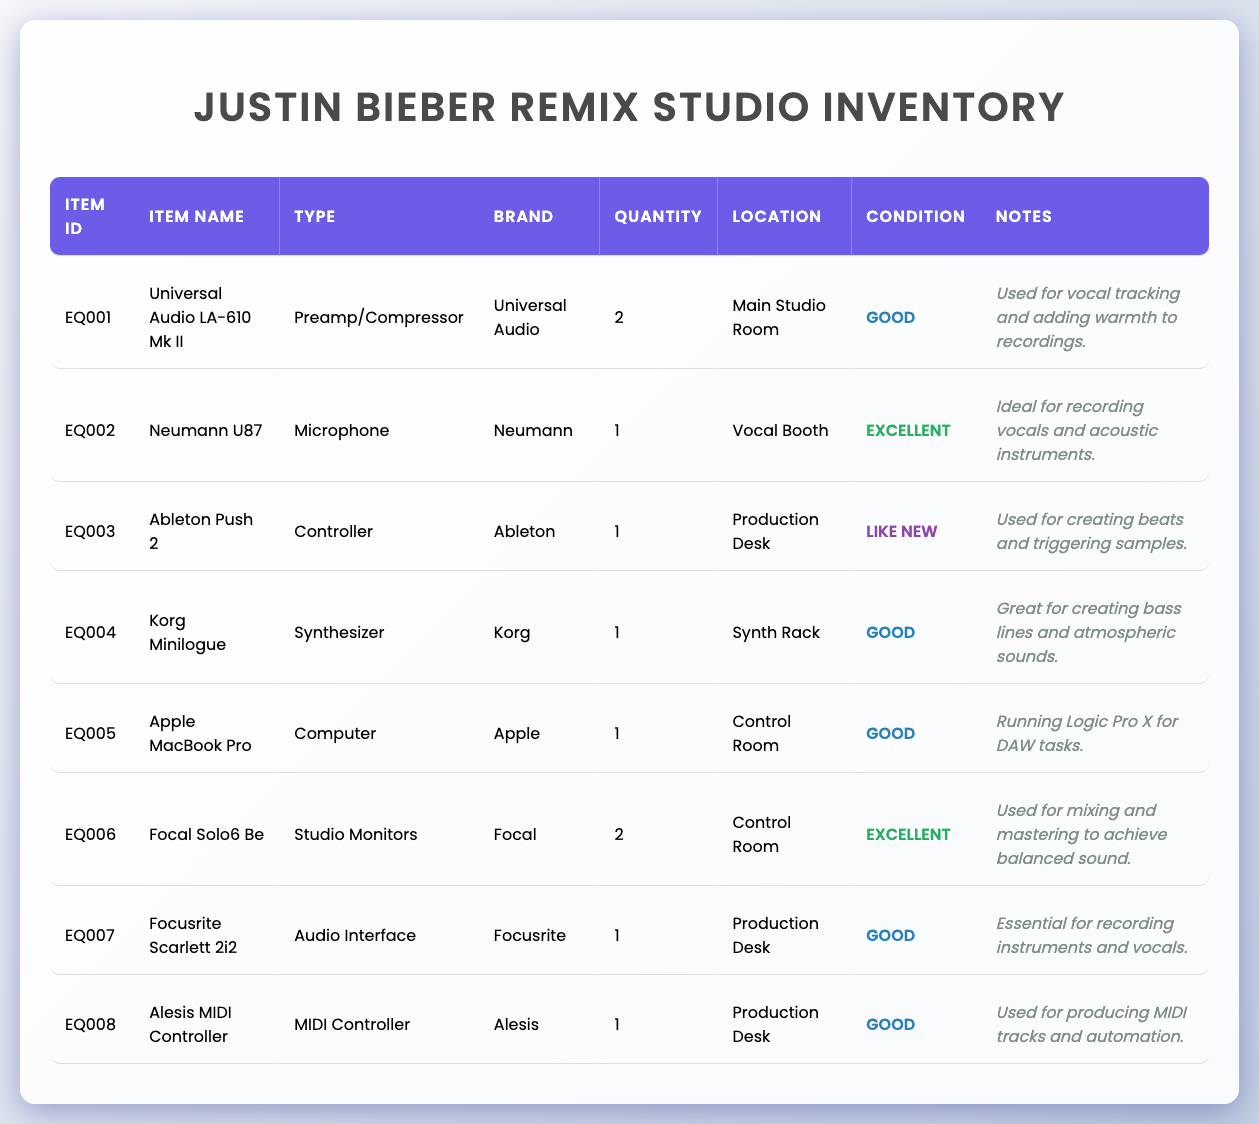What is the location of the Neumann U87 microphone? The Neumann U87 microphone is listed in the "Location" column, which shows it is in the "Vocal Booth."
Answer: Vocal Booth How many studio monitors are in the inventory? The "Quantity" column for "Focal Solo6 Be" shows there are 2 studio monitors listed in the inventory.
Answer: 2 Is the Universal Audio LA-610 Mk II in excellent condition? Looking at the "Condition" column, the Universal Audio LA-610 Mk II is noted as being in "Good" condition, not excellent.
Answer: No What type of equipment is the Apple MacBook Pro? The "Type" column specifies that the Apple MacBook Pro is classified as a "Computer."
Answer: Computer Which equipment has the note mentioning it is used for mixing and mastering? By reviewing the "Notes" column, the "Focal Solo6 Be" has a note stating it is "Used for mixing and mastering to achieve balanced sound."
Answer: Focal Solo6 Be How many items in the inventory are labeled as being in "Excellent" condition? From the "Condition" column, the Neumann U87 and Focal Solo6 Be are both labeled as being "Excellent," resulting in a total of 2 items in that condition.
Answer: 2 What is the total number of preamps/compressors in the inventory? According to the "item_type" column, only the Universal Audio LA-610 Mk II falls into the category of "Preamp/Compressor," giving a total of 1.
Answer: 1 Which piece of equipment is used for creating beats and triggering samples? The "Notes" column notes that the "Ableton Push 2" is used specifically for "creating beats and triggering samples."
Answer: Ableton Push 2 Is there any equipment from the brand "Alesis"? The inventory includes the "Alesis MIDI Controller," confirming that there is equipment from the brand Alesis.
Answer: Yes 